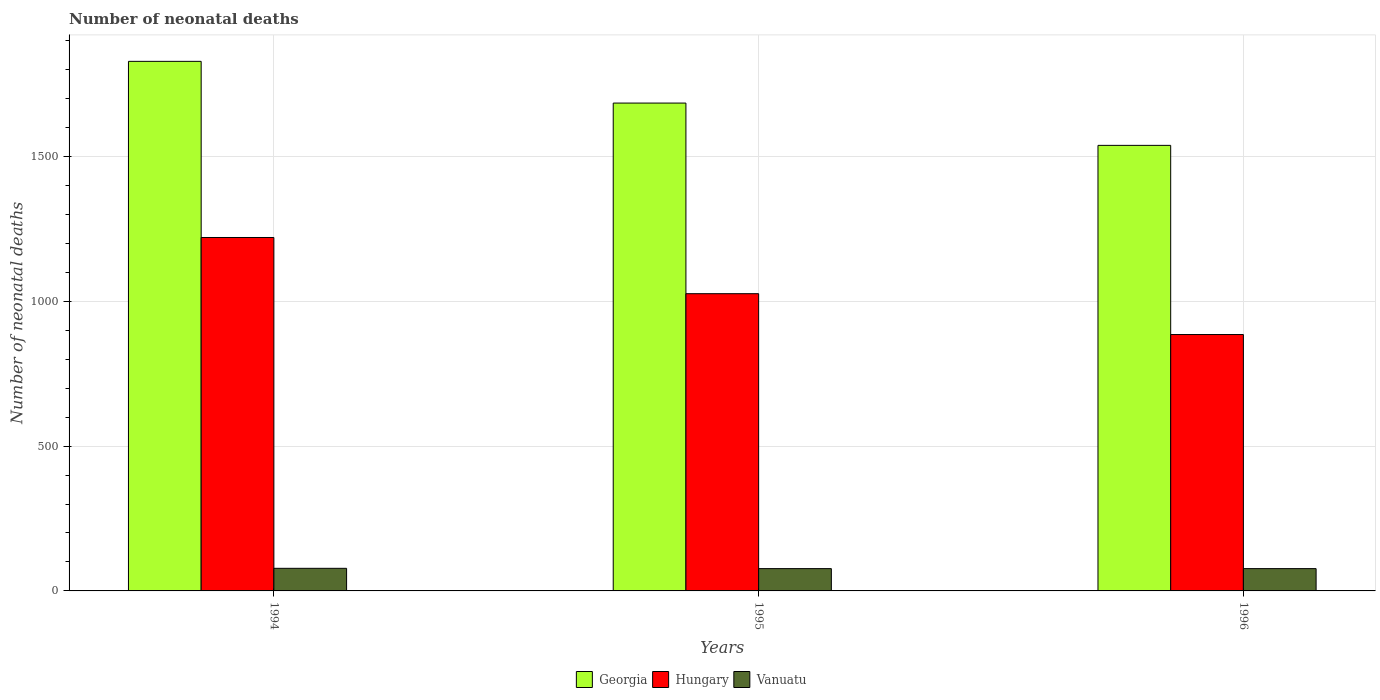How many different coloured bars are there?
Provide a succinct answer. 3. Are the number of bars per tick equal to the number of legend labels?
Provide a succinct answer. Yes. How many bars are there on the 1st tick from the left?
Offer a very short reply. 3. What is the label of the 3rd group of bars from the left?
Offer a terse response. 1996. In how many cases, is the number of bars for a given year not equal to the number of legend labels?
Keep it short and to the point. 0. What is the number of neonatal deaths in in Georgia in 1994?
Provide a succinct answer. 1828. Across all years, what is the maximum number of neonatal deaths in in Georgia?
Offer a terse response. 1828. Across all years, what is the minimum number of neonatal deaths in in Georgia?
Give a very brief answer. 1538. In which year was the number of neonatal deaths in in Vanuatu minimum?
Ensure brevity in your answer.  1995. What is the total number of neonatal deaths in in Vanuatu in the graph?
Keep it short and to the point. 232. What is the difference between the number of neonatal deaths in in Vanuatu in 1995 and that in 1996?
Keep it short and to the point. 0. What is the difference between the number of neonatal deaths in in Georgia in 1996 and the number of neonatal deaths in in Vanuatu in 1994?
Your answer should be very brief. 1460. What is the average number of neonatal deaths in in Georgia per year?
Make the answer very short. 1683.33. In the year 1995, what is the difference between the number of neonatal deaths in in Vanuatu and number of neonatal deaths in in Georgia?
Provide a succinct answer. -1607. In how many years, is the number of neonatal deaths in in Vanuatu greater than 800?
Provide a succinct answer. 0. What is the ratio of the number of neonatal deaths in in Hungary in 1994 to that in 1996?
Keep it short and to the point. 1.38. Is the difference between the number of neonatal deaths in in Vanuatu in 1994 and 1996 greater than the difference between the number of neonatal deaths in in Georgia in 1994 and 1996?
Provide a succinct answer. No. What is the difference between the highest and the second highest number of neonatal deaths in in Hungary?
Give a very brief answer. 194. What is the difference between the highest and the lowest number of neonatal deaths in in Georgia?
Your answer should be compact. 290. Is the sum of the number of neonatal deaths in in Georgia in 1994 and 1995 greater than the maximum number of neonatal deaths in in Vanuatu across all years?
Give a very brief answer. Yes. What does the 2nd bar from the left in 1996 represents?
Offer a terse response. Hungary. What does the 2nd bar from the right in 1994 represents?
Offer a very short reply. Hungary. Is it the case that in every year, the sum of the number of neonatal deaths in in Vanuatu and number of neonatal deaths in in Hungary is greater than the number of neonatal deaths in in Georgia?
Keep it short and to the point. No. Are all the bars in the graph horizontal?
Offer a terse response. No. How many years are there in the graph?
Make the answer very short. 3. Where does the legend appear in the graph?
Keep it short and to the point. Bottom center. How many legend labels are there?
Keep it short and to the point. 3. How are the legend labels stacked?
Keep it short and to the point. Horizontal. What is the title of the graph?
Give a very brief answer. Number of neonatal deaths. What is the label or title of the Y-axis?
Your response must be concise. Number of neonatal deaths. What is the Number of neonatal deaths of Georgia in 1994?
Offer a terse response. 1828. What is the Number of neonatal deaths of Hungary in 1994?
Your answer should be very brief. 1220. What is the Number of neonatal deaths in Georgia in 1995?
Ensure brevity in your answer.  1684. What is the Number of neonatal deaths of Hungary in 1995?
Keep it short and to the point. 1026. What is the Number of neonatal deaths of Vanuatu in 1995?
Provide a short and direct response. 77. What is the Number of neonatal deaths in Georgia in 1996?
Provide a short and direct response. 1538. What is the Number of neonatal deaths of Hungary in 1996?
Keep it short and to the point. 885. What is the Number of neonatal deaths of Vanuatu in 1996?
Make the answer very short. 77. Across all years, what is the maximum Number of neonatal deaths in Georgia?
Keep it short and to the point. 1828. Across all years, what is the maximum Number of neonatal deaths in Hungary?
Offer a terse response. 1220. Across all years, what is the minimum Number of neonatal deaths in Georgia?
Give a very brief answer. 1538. Across all years, what is the minimum Number of neonatal deaths in Hungary?
Your answer should be very brief. 885. What is the total Number of neonatal deaths in Georgia in the graph?
Offer a very short reply. 5050. What is the total Number of neonatal deaths in Hungary in the graph?
Your answer should be compact. 3131. What is the total Number of neonatal deaths in Vanuatu in the graph?
Your answer should be compact. 232. What is the difference between the Number of neonatal deaths in Georgia in 1994 and that in 1995?
Your response must be concise. 144. What is the difference between the Number of neonatal deaths in Hungary in 1994 and that in 1995?
Your answer should be very brief. 194. What is the difference between the Number of neonatal deaths of Georgia in 1994 and that in 1996?
Ensure brevity in your answer.  290. What is the difference between the Number of neonatal deaths of Hungary in 1994 and that in 1996?
Your answer should be very brief. 335. What is the difference between the Number of neonatal deaths in Georgia in 1995 and that in 1996?
Give a very brief answer. 146. What is the difference between the Number of neonatal deaths of Hungary in 1995 and that in 1996?
Offer a very short reply. 141. What is the difference between the Number of neonatal deaths of Georgia in 1994 and the Number of neonatal deaths of Hungary in 1995?
Keep it short and to the point. 802. What is the difference between the Number of neonatal deaths in Georgia in 1994 and the Number of neonatal deaths in Vanuatu in 1995?
Give a very brief answer. 1751. What is the difference between the Number of neonatal deaths of Hungary in 1994 and the Number of neonatal deaths of Vanuatu in 1995?
Your answer should be compact. 1143. What is the difference between the Number of neonatal deaths in Georgia in 1994 and the Number of neonatal deaths in Hungary in 1996?
Ensure brevity in your answer.  943. What is the difference between the Number of neonatal deaths in Georgia in 1994 and the Number of neonatal deaths in Vanuatu in 1996?
Provide a succinct answer. 1751. What is the difference between the Number of neonatal deaths of Hungary in 1994 and the Number of neonatal deaths of Vanuatu in 1996?
Give a very brief answer. 1143. What is the difference between the Number of neonatal deaths of Georgia in 1995 and the Number of neonatal deaths of Hungary in 1996?
Provide a succinct answer. 799. What is the difference between the Number of neonatal deaths in Georgia in 1995 and the Number of neonatal deaths in Vanuatu in 1996?
Provide a succinct answer. 1607. What is the difference between the Number of neonatal deaths of Hungary in 1995 and the Number of neonatal deaths of Vanuatu in 1996?
Give a very brief answer. 949. What is the average Number of neonatal deaths of Georgia per year?
Ensure brevity in your answer.  1683.33. What is the average Number of neonatal deaths of Hungary per year?
Keep it short and to the point. 1043.67. What is the average Number of neonatal deaths in Vanuatu per year?
Offer a very short reply. 77.33. In the year 1994, what is the difference between the Number of neonatal deaths in Georgia and Number of neonatal deaths in Hungary?
Offer a terse response. 608. In the year 1994, what is the difference between the Number of neonatal deaths in Georgia and Number of neonatal deaths in Vanuatu?
Your response must be concise. 1750. In the year 1994, what is the difference between the Number of neonatal deaths of Hungary and Number of neonatal deaths of Vanuatu?
Offer a terse response. 1142. In the year 1995, what is the difference between the Number of neonatal deaths of Georgia and Number of neonatal deaths of Hungary?
Provide a short and direct response. 658. In the year 1995, what is the difference between the Number of neonatal deaths in Georgia and Number of neonatal deaths in Vanuatu?
Offer a terse response. 1607. In the year 1995, what is the difference between the Number of neonatal deaths of Hungary and Number of neonatal deaths of Vanuatu?
Offer a terse response. 949. In the year 1996, what is the difference between the Number of neonatal deaths in Georgia and Number of neonatal deaths in Hungary?
Give a very brief answer. 653. In the year 1996, what is the difference between the Number of neonatal deaths in Georgia and Number of neonatal deaths in Vanuatu?
Provide a succinct answer. 1461. In the year 1996, what is the difference between the Number of neonatal deaths in Hungary and Number of neonatal deaths in Vanuatu?
Your answer should be very brief. 808. What is the ratio of the Number of neonatal deaths in Georgia in 1994 to that in 1995?
Ensure brevity in your answer.  1.09. What is the ratio of the Number of neonatal deaths of Hungary in 1994 to that in 1995?
Give a very brief answer. 1.19. What is the ratio of the Number of neonatal deaths in Georgia in 1994 to that in 1996?
Your answer should be very brief. 1.19. What is the ratio of the Number of neonatal deaths of Hungary in 1994 to that in 1996?
Give a very brief answer. 1.38. What is the ratio of the Number of neonatal deaths in Vanuatu in 1994 to that in 1996?
Your answer should be compact. 1.01. What is the ratio of the Number of neonatal deaths in Georgia in 1995 to that in 1996?
Your response must be concise. 1.09. What is the ratio of the Number of neonatal deaths in Hungary in 1995 to that in 1996?
Ensure brevity in your answer.  1.16. What is the ratio of the Number of neonatal deaths of Vanuatu in 1995 to that in 1996?
Make the answer very short. 1. What is the difference between the highest and the second highest Number of neonatal deaths in Georgia?
Offer a terse response. 144. What is the difference between the highest and the second highest Number of neonatal deaths in Hungary?
Offer a very short reply. 194. What is the difference between the highest and the lowest Number of neonatal deaths of Georgia?
Your response must be concise. 290. What is the difference between the highest and the lowest Number of neonatal deaths of Hungary?
Keep it short and to the point. 335. 